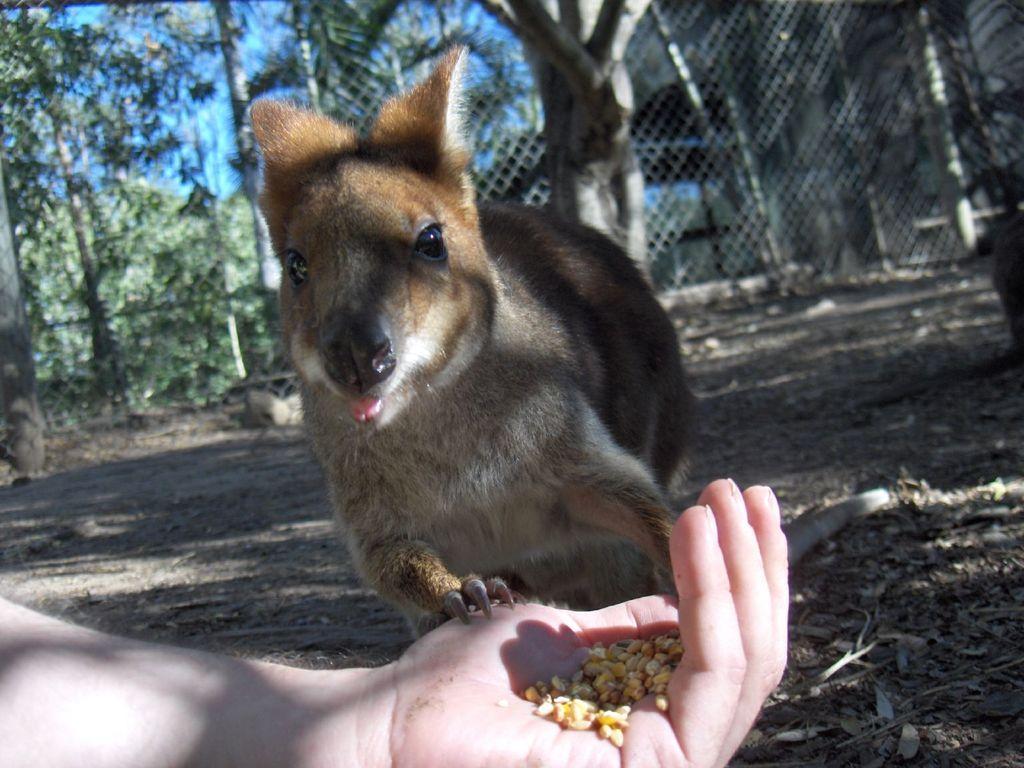Could you give a brief overview of what you see in this image? This picture is clicked outside. In the foreground we can see the hand of a person holding some food item and there is an animal seems to be standing. In the background we can see the sky, trees, poles, metal rods and some plants. 